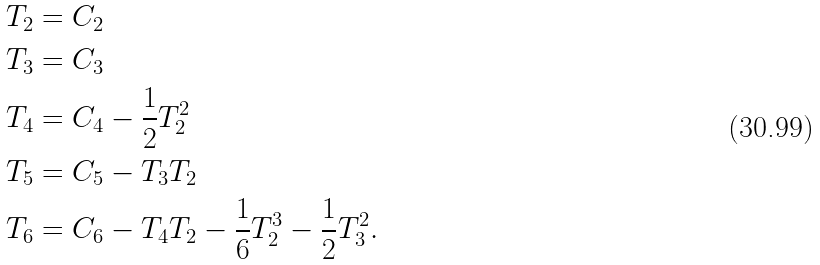Convert formula to latex. <formula><loc_0><loc_0><loc_500><loc_500>T _ { 2 } & = C _ { 2 } \\ T _ { 3 } & = C _ { 3 } \\ T _ { 4 } & = C _ { 4 } - \frac { 1 } { 2 } T _ { 2 } ^ { 2 } \\ T _ { 5 } & = C _ { 5 } - T _ { 3 } T _ { 2 } \\ T _ { 6 } & = C _ { 6 } - T _ { 4 } T _ { 2 } - \frac { 1 } { 6 } T _ { 2 } ^ { 3 } - \frac { 1 } { 2 } T _ { 3 } ^ { 2 } .</formula> 